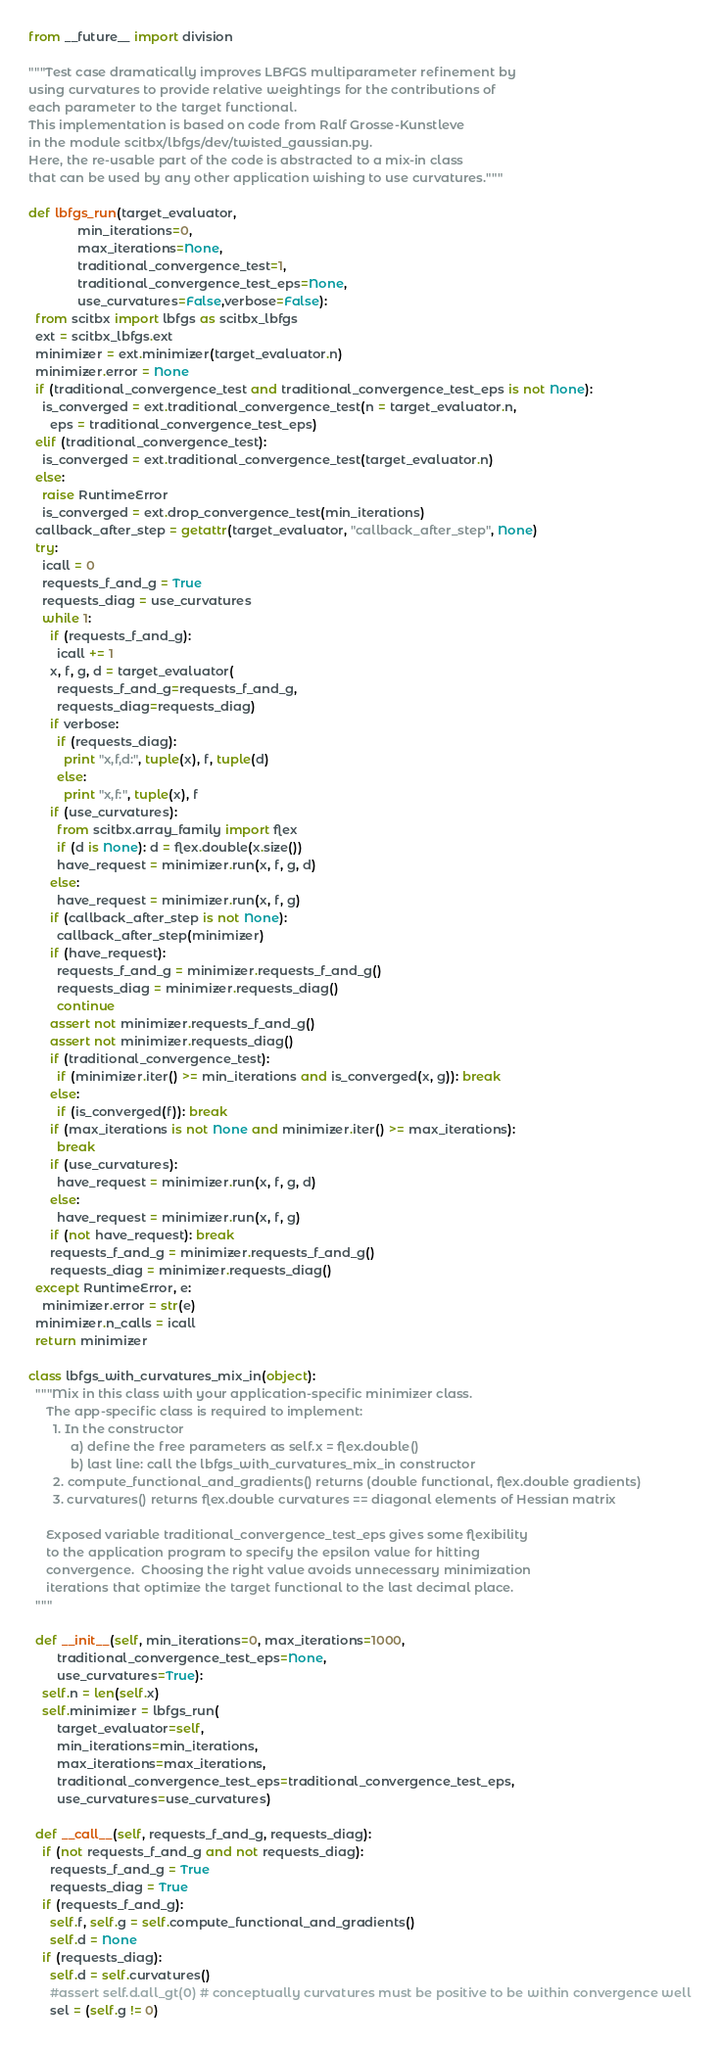<code> <loc_0><loc_0><loc_500><loc_500><_Python_>from __future__ import division

"""Test case dramatically improves LBFGS multiparameter refinement by
using curvatures to provide relative weightings for the contributions of
each parameter to the target functional.
This implementation is based on code from Ralf Grosse-Kunstleve
in the module scitbx/lbfgs/dev/twisted_gaussian.py.
Here, the re-usable part of the code is abstracted to a mix-in class
that can be used by any other application wishing to use curvatures."""

def lbfgs_run(target_evaluator,
              min_iterations=0,
              max_iterations=None,
              traditional_convergence_test=1,
              traditional_convergence_test_eps=None,
              use_curvatures=False,verbose=False):
  from scitbx import lbfgs as scitbx_lbfgs
  ext = scitbx_lbfgs.ext
  minimizer = ext.minimizer(target_evaluator.n)
  minimizer.error = None
  if (traditional_convergence_test and traditional_convergence_test_eps is not None):
    is_converged = ext.traditional_convergence_test(n = target_evaluator.n,
      eps = traditional_convergence_test_eps)
  elif (traditional_convergence_test):
    is_converged = ext.traditional_convergence_test(target_evaluator.n)
  else:
    raise RuntimeError
    is_converged = ext.drop_convergence_test(min_iterations)
  callback_after_step = getattr(target_evaluator, "callback_after_step", None)
  try:
    icall = 0
    requests_f_and_g = True
    requests_diag = use_curvatures
    while 1:
      if (requests_f_and_g):
        icall += 1
      x, f, g, d = target_evaluator(
        requests_f_and_g=requests_f_and_g,
        requests_diag=requests_diag)
      if verbose:
        if (requests_diag):
          print "x,f,d:", tuple(x), f, tuple(d)
        else:
          print "x,f:", tuple(x), f
      if (use_curvatures):
        from scitbx.array_family import flex
        if (d is None): d = flex.double(x.size())
        have_request = minimizer.run(x, f, g, d)
      else:
        have_request = minimizer.run(x, f, g)
      if (callback_after_step is not None):
        callback_after_step(minimizer)
      if (have_request):
        requests_f_and_g = minimizer.requests_f_and_g()
        requests_diag = minimizer.requests_diag()
        continue
      assert not minimizer.requests_f_and_g()
      assert not minimizer.requests_diag()
      if (traditional_convergence_test):
        if (minimizer.iter() >= min_iterations and is_converged(x, g)): break
      else:
        if (is_converged(f)): break
      if (max_iterations is not None and minimizer.iter() >= max_iterations):
        break
      if (use_curvatures):
        have_request = minimizer.run(x, f, g, d)
      else:
        have_request = minimizer.run(x, f, g)
      if (not have_request): break
      requests_f_and_g = minimizer.requests_f_and_g()
      requests_diag = minimizer.requests_diag()
  except RuntimeError, e:
    minimizer.error = str(e)
  minimizer.n_calls = icall
  return minimizer

class lbfgs_with_curvatures_mix_in(object):
  """Mix in this class with your application-specific minimizer class.
     The app-specific class is required to implement:
       1. In the constructor
            a) define the free parameters as self.x = flex.double()
            b) last line: call the lbfgs_with_curvatures_mix_in constructor
       2. compute_functional_and_gradients() returns (double functional, flex.double gradients)
       3. curvatures() returns flex.double curvatures == diagonal elements of Hessian matrix

     Exposed variable traditional_convergence_test_eps gives some flexibility
     to the application program to specify the epsilon value for hitting
     convergence.  Choosing the right value avoids unnecessary minimization
     iterations that optimize the target functional to the last decimal place.
  """

  def __init__(self, min_iterations=0, max_iterations=1000,
        traditional_convergence_test_eps=None,
        use_curvatures=True):
    self.n = len(self.x)
    self.minimizer = lbfgs_run(
        target_evaluator=self,
        min_iterations=min_iterations,
        max_iterations=max_iterations,
        traditional_convergence_test_eps=traditional_convergence_test_eps,
        use_curvatures=use_curvatures)

  def __call__(self, requests_f_and_g, requests_diag):
    if (not requests_f_and_g and not requests_diag):
      requests_f_and_g = True
      requests_diag = True
    if (requests_f_and_g):
      self.f, self.g = self.compute_functional_and_gradients()
      self.d = None
    if (requests_diag):
      self.d = self.curvatures()
      #assert self.d.all_gt(0) # conceptually curvatures must be positive to be within convergence well
      sel = (self.g != 0)</code> 